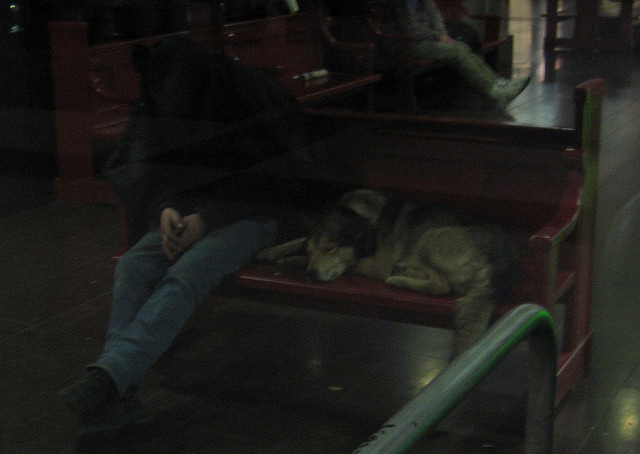Describe the objects in this image and their specific colors. I can see bench in black and darkgreen tones, people in black and darkblue tones, bench in black, gray, and darkgreen tones, dog in black and darkgreen tones, and bench in black and brown tones in this image. 